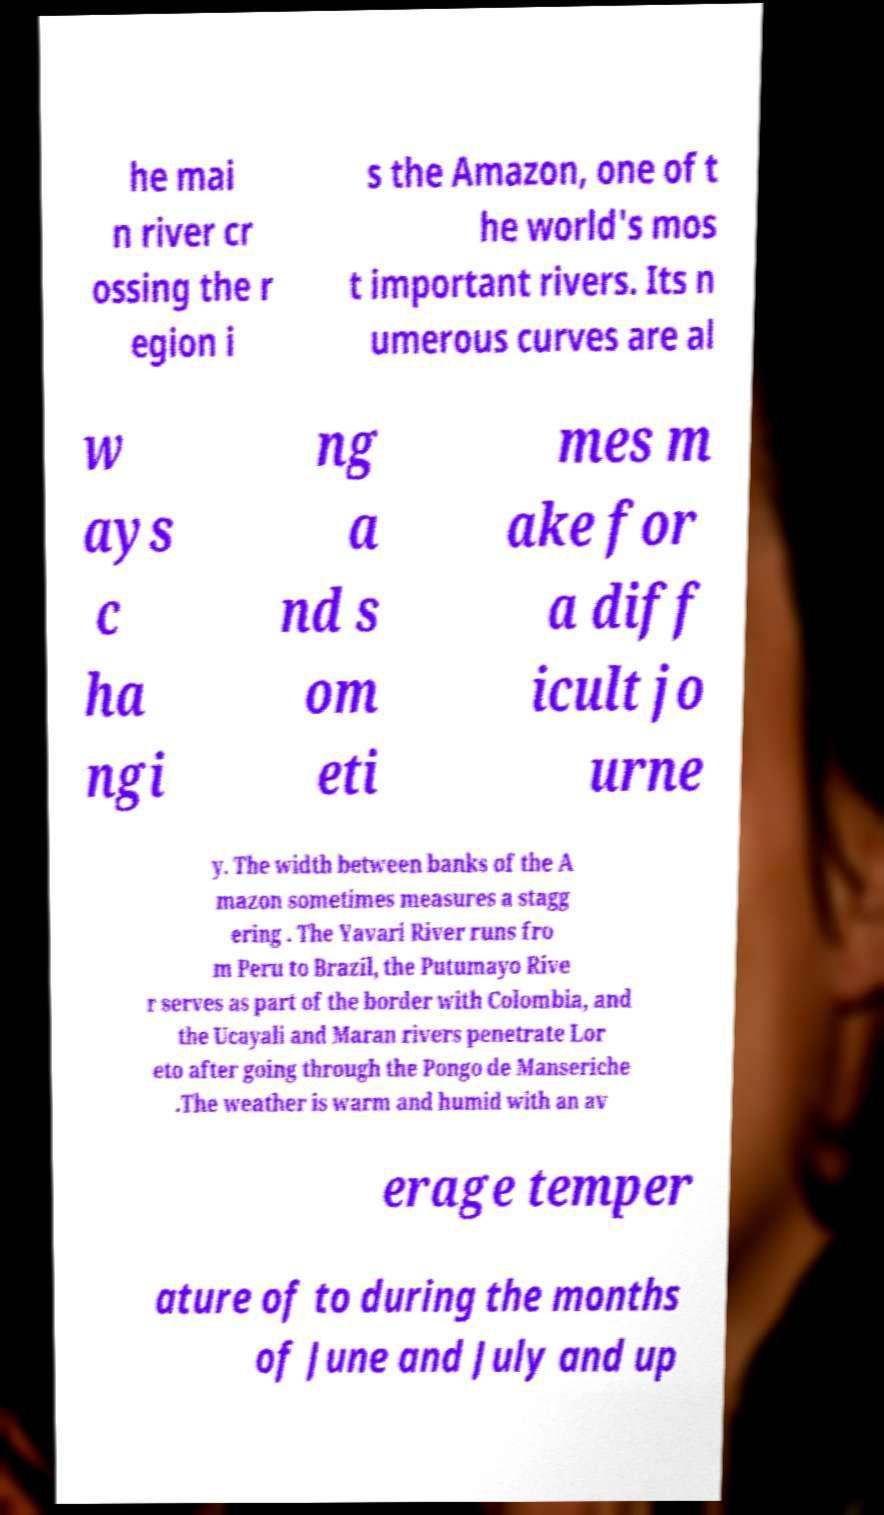There's text embedded in this image that I need extracted. Can you transcribe it verbatim? he mai n river cr ossing the r egion i s the Amazon, one of t he world's mos t important rivers. Its n umerous curves are al w ays c ha ngi ng a nd s om eti mes m ake for a diff icult jo urne y. The width between banks of the A mazon sometimes measures a stagg ering . The Yavari River runs fro m Peru to Brazil, the Putumayo Rive r serves as part of the border with Colombia, and the Ucayali and Maran rivers penetrate Lor eto after going through the Pongo de Manseriche .The weather is warm and humid with an av erage temper ature of to during the months of June and July and up 